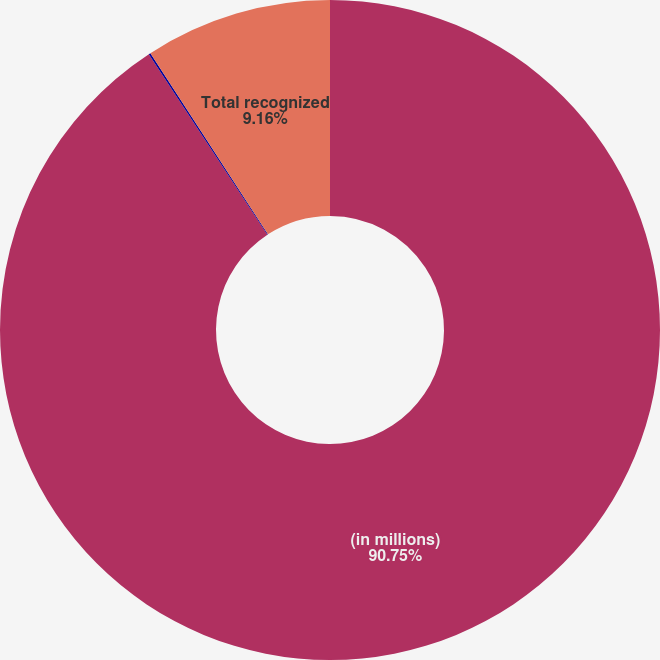<chart> <loc_0><loc_0><loc_500><loc_500><pie_chart><fcel>(in millions)<fcel>Net actuarial loss (gain)<fcel>Total recognized<nl><fcel>90.75%<fcel>0.09%<fcel>9.16%<nl></chart> 